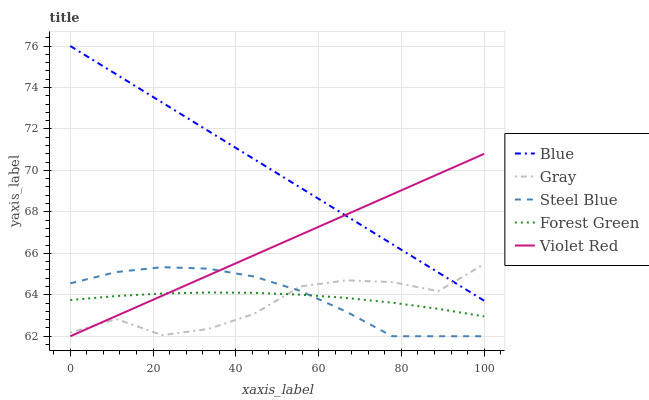Does Gray have the minimum area under the curve?
Answer yes or no. Yes. Does Blue have the maximum area under the curve?
Answer yes or no. Yes. Does Forest Green have the minimum area under the curve?
Answer yes or no. No. Does Forest Green have the maximum area under the curve?
Answer yes or no. No. Is Blue the smoothest?
Answer yes or no. Yes. Is Gray the roughest?
Answer yes or no. Yes. Is Forest Green the smoothest?
Answer yes or no. No. Is Forest Green the roughest?
Answer yes or no. No. Does Steel Blue have the lowest value?
Answer yes or no. Yes. Does Gray have the lowest value?
Answer yes or no. No. Does Blue have the highest value?
Answer yes or no. Yes. Does Gray have the highest value?
Answer yes or no. No. Is Forest Green less than Blue?
Answer yes or no. Yes. Is Blue greater than Steel Blue?
Answer yes or no. Yes. Does Forest Green intersect Steel Blue?
Answer yes or no. Yes. Is Forest Green less than Steel Blue?
Answer yes or no. No. Is Forest Green greater than Steel Blue?
Answer yes or no. No. Does Forest Green intersect Blue?
Answer yes or no. No. 